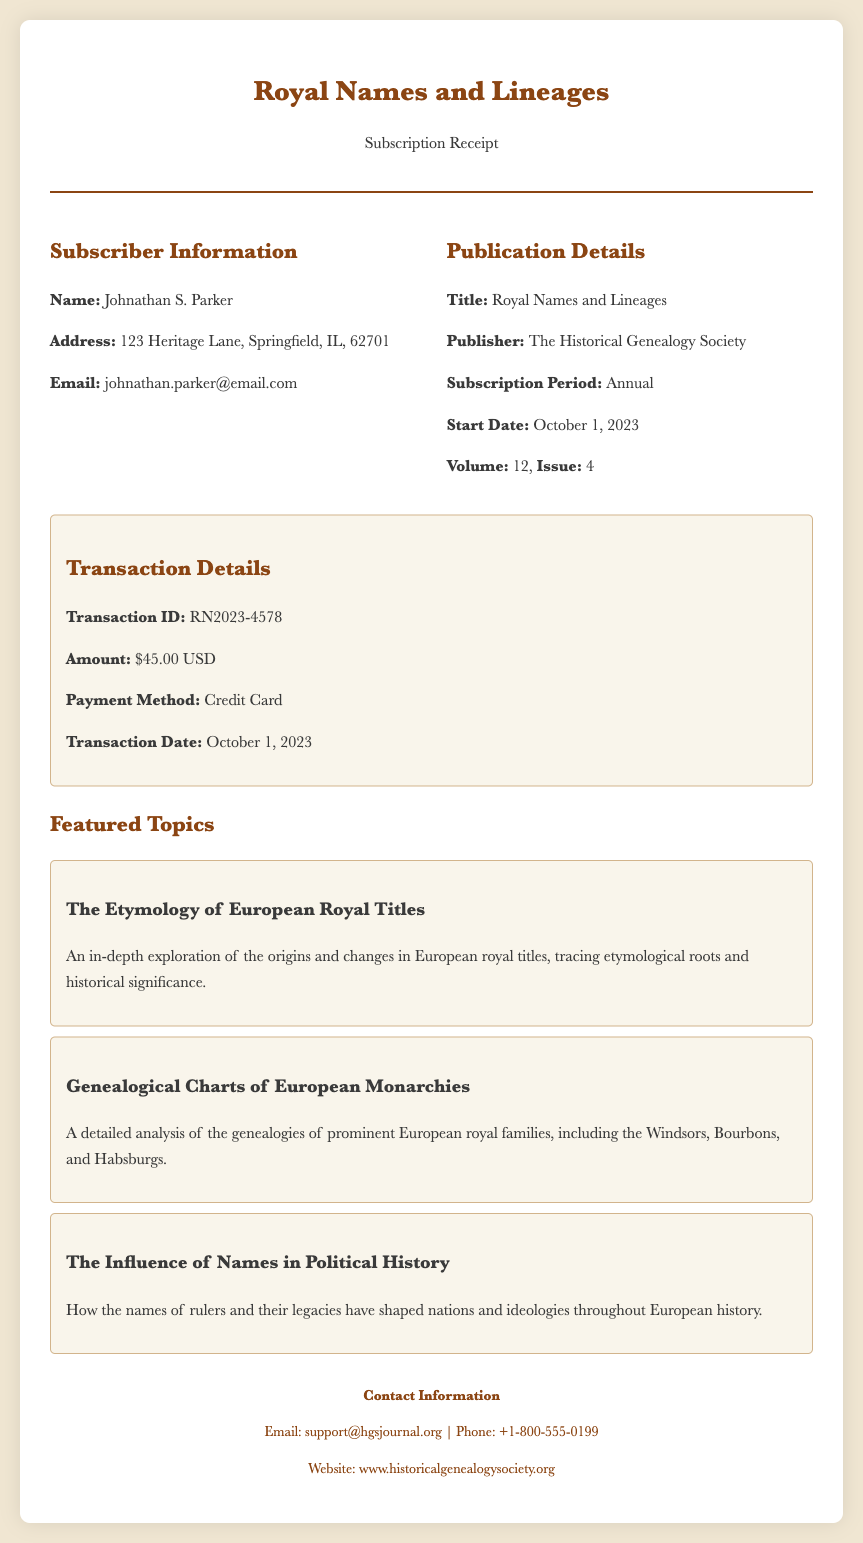What is the subscriber's name? The document provides the subscriber's name as Johnathan S. Parker.
Answer: Johnathan S. Parker What is the subscription period? The subscription period mentioned in the document is Annual.
Answer: Annual What is the transaction amount? The document states that the transaction amount is $45.00 USD.
Answer: $45.00 USD What is the volume number of the publication? The volume number in the document is specified as 12.
Answer: 12 What is the email address of the subscriber? The document lists the subscriber's email address as johnathan.parker@email.com.
Answer: johnathan.parker@email.com What date does the subscription start? According to the document, the subscription starts on October 1, 2023.
Answer: October 1, 2023 What is the Transaction ID? The transaction ID mentioned in the document is RN2023-4578.
Answer: RN2023-4578 How many featured topics are listed in the document? The document lists three featured topics under the Features section.
Answer: 3 Who is the publisher of the journal? The publisher of the journal, as stated in the document, is The Historical Genealogy Society.
Answer: The Historical Genealogy Society What payment method was used for the transaction? The document indicates that the payment method used was Credit Card.
Answer: Credit Card 